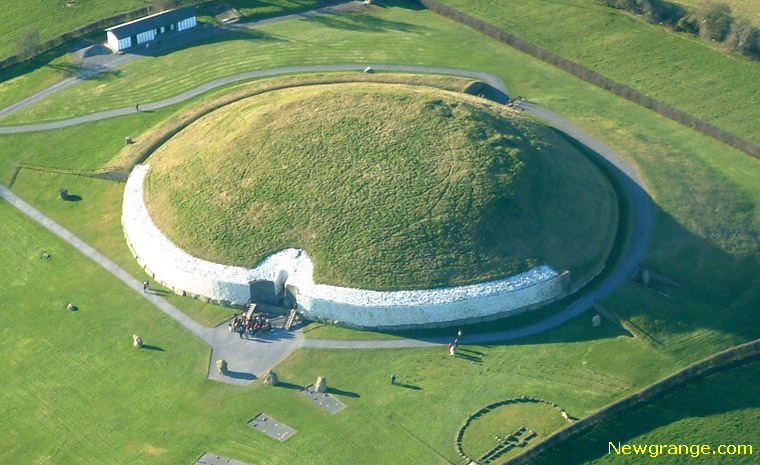How do you think Newgrange fits into the story of human advancement and civilization? Newgrange is a testament to the ingenuity and sophistication of early human civilization. Its construction reflects a deep understanding of architecture, engineering, and astronomy, showcasing the ability of Neolithic people to undertake complex projects and work collaboratively. It also highlights the importance of spiritual and religious practices in early societies, suggesting a belief system that revered the cycles of nature and celestial events. In the broader narrative of human advancement, Newgrange serves as a milestone that underscores the intellectual and cultural achievements of our ancestors, bridging the gap between prehistoric simplicity and the advanced civilizations that followed. 